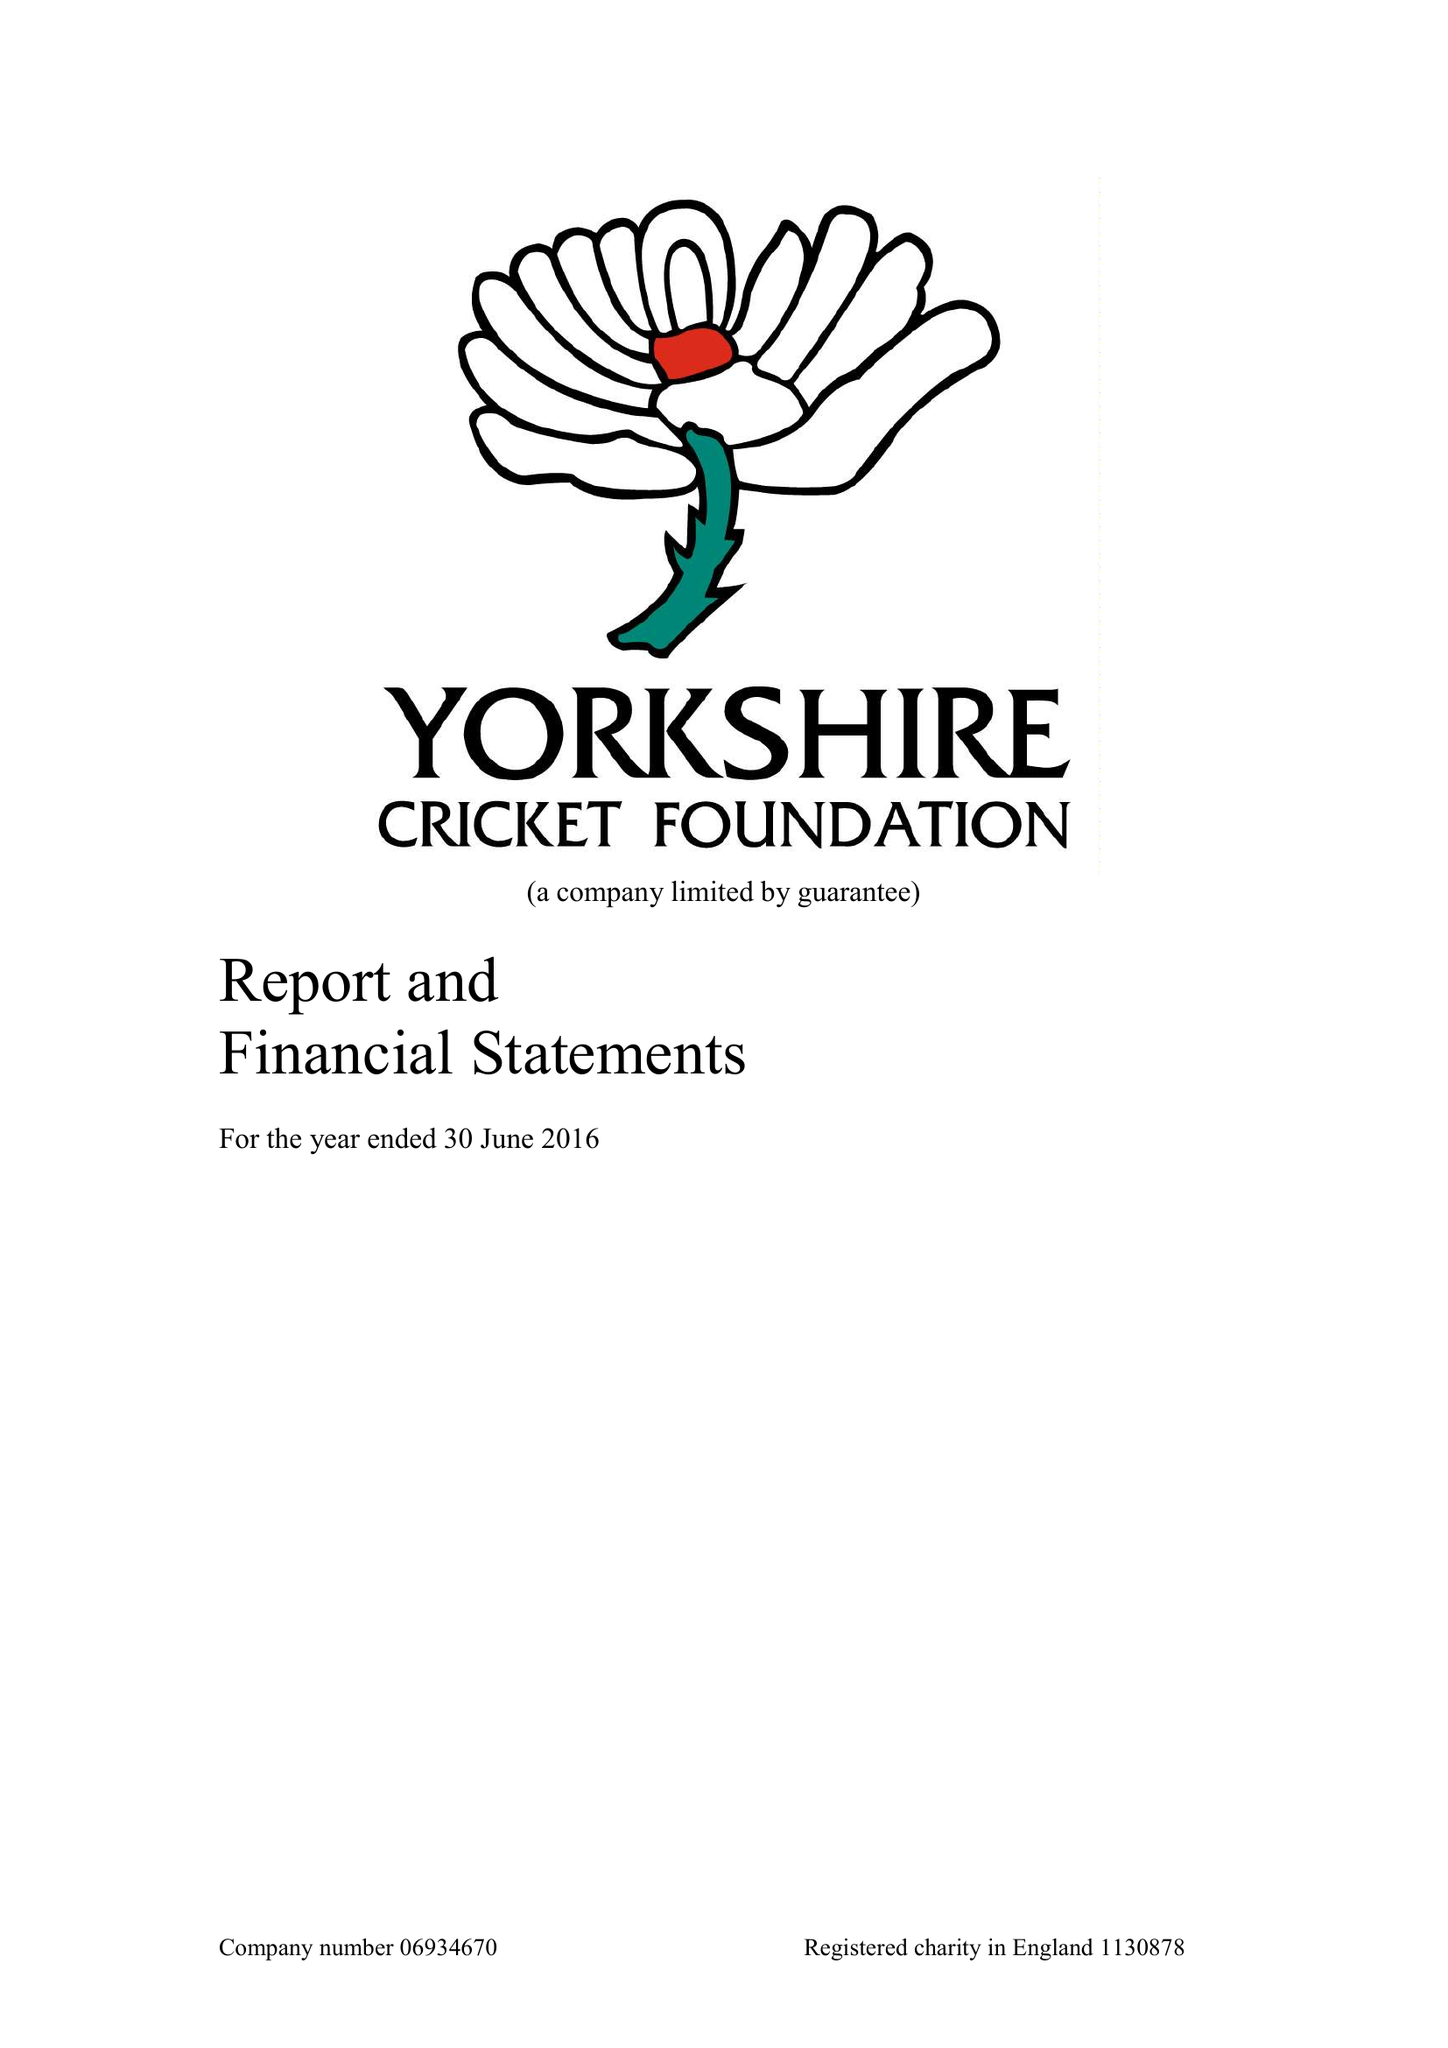What is the value for the address__postcode?
Answer the question using a single word or phrase. LS6 3DP 